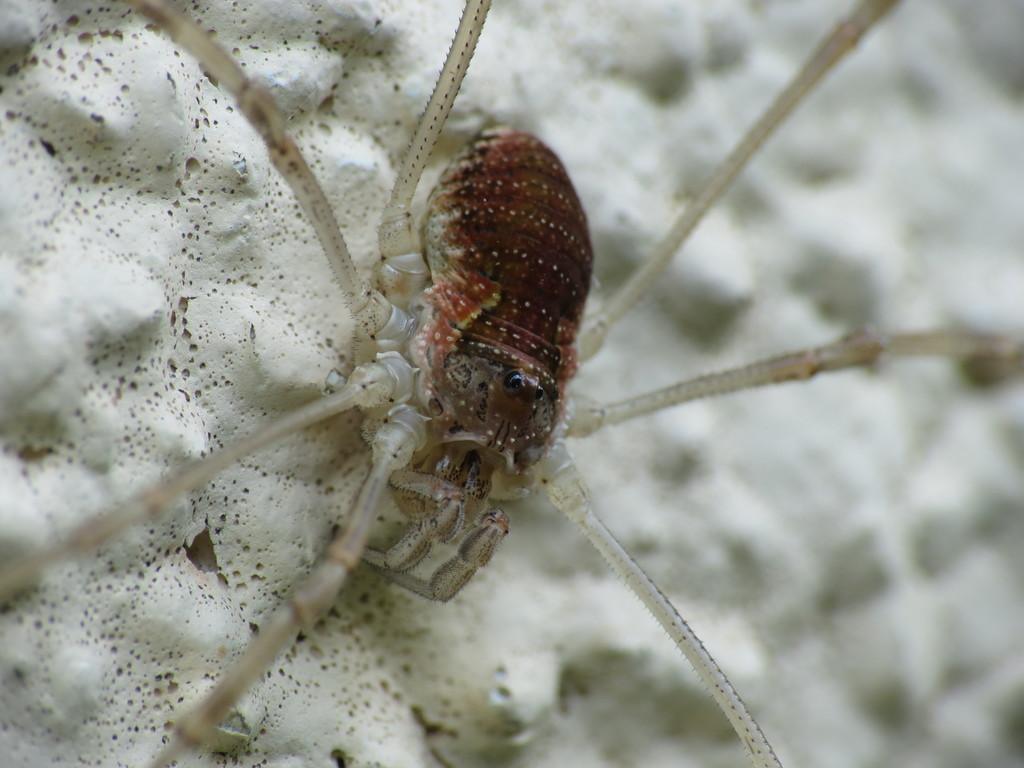Could you give a brief overview of what you see in this image? In the picture there is an insect present on the white surface. 